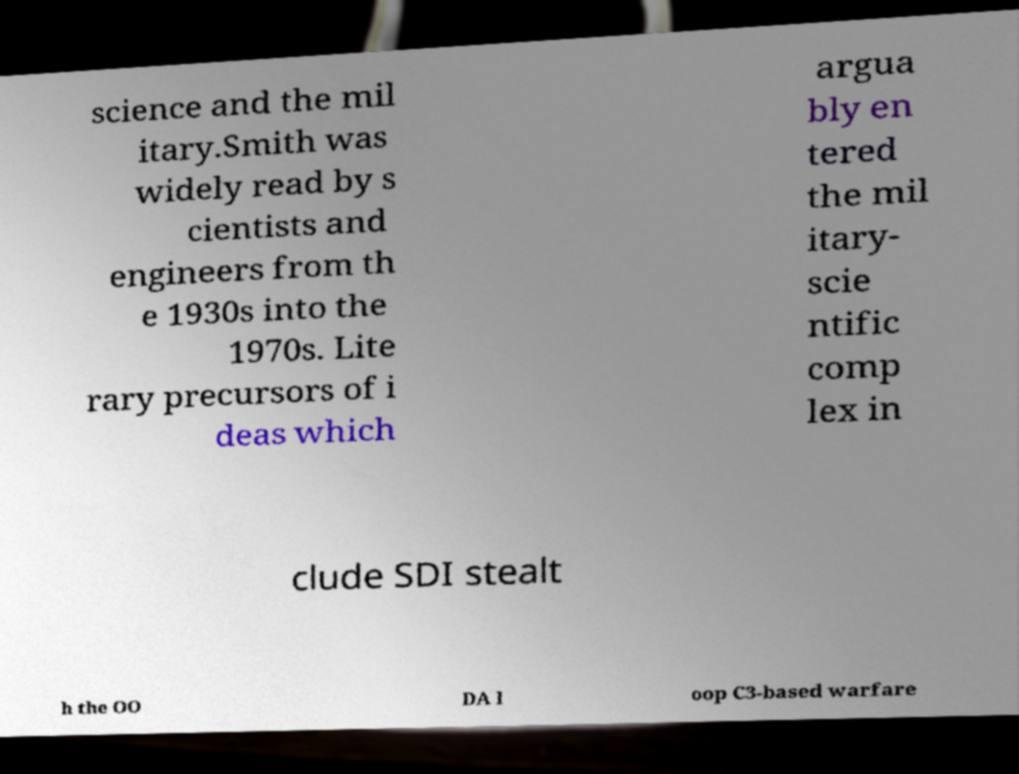Can you read and provide the text displayed in the image?This photo seems to have some interesting text. Can you extract and type it out for me? science and the mil itary.Smith was widely read by s cientists and engineers from th e 1930s into the 1970s. Lite rary precursors of i deas which argua bly en tered the mil itary- scie ntific comp lex in clude SDI stealt h the OO DA l oop C3-based warfare 